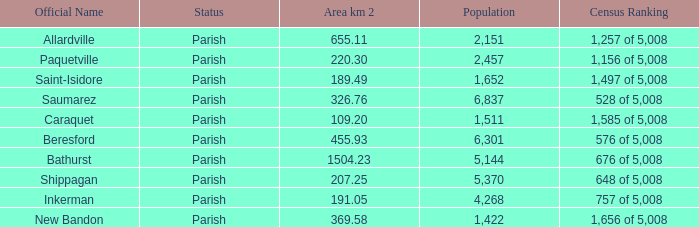What is the Area of the Allardville Parish with a Population smaller than 2,151? None. 